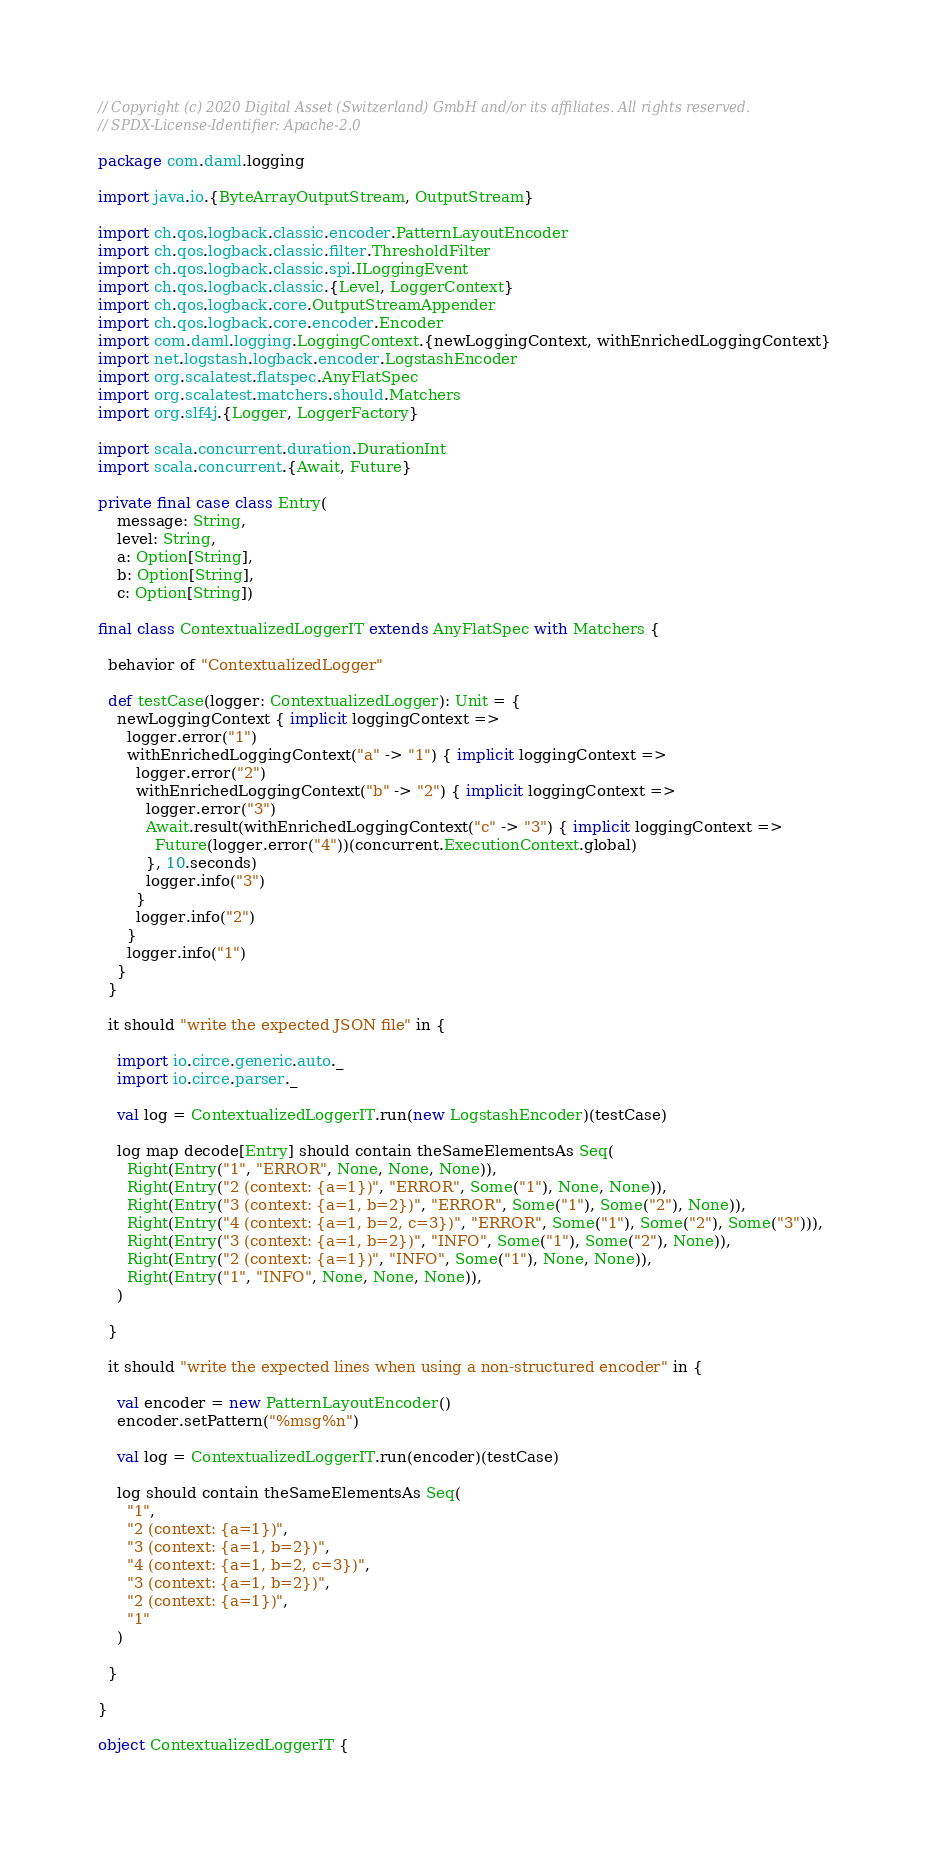<code> <loc_0><loc_0><loc_500><loc_500><_Scala_>// Copyright (c) 2020 Digital Asset (Switzerland) GmbH and/or its affiliates. All rights reserved.
// SPDX-License-Identifier: Apache-2.0

package com.daml.logging

import java.io.{ByteArrayOutputStream, OutputStream}

import ch.qos.logback.classic.encoder.PatternLayoutEncoder
import ch.qos.logback.classic.filter.ThresholdFilter
import ch.qos.logback.classic.spi.ILoggingEvent
import ch.qos.logback.classic.{Level, LoggerContext}
import ch.qos.logback.core.OutputStreamAppender
import ch.qos.logback.core.encoder.Encoder
import com.daml.logging.LoggingContext.{newLoggingContext, withEnrichedLoggingContext}
import net.logstash.logback.encoder.LogstashEncoder
import org.scalatest.flatspec.AnyFlatSpec
import org.scalatest.matchers.should.Matchers
import org.slf4j.{Logger, LoggerFactory}

import scala.concurrent.duration.DurationInt
import scala.concurrent.{Await, Future}

private final case class Entry(
    message: String,
    level: String,
    a: Option[String],
    b: Option[String],
    c: Option[String])

final class ContextualizedLoggerIT extends AnyFlatSpec with Matchers {

  behavior of "ContextualizedLogger"

  def testCase(logger: ContextualizedLogger): Unit = {
    newLoggingContext { implicit loggingContext =>
      logger.error("1")
      withEnrichedLoggingContext("a" -> "1") { implicit loggingContext =>
        logger.error("2")
        withEnrichedLoggingContext("b" -> "2") { implicit loggingContext =>
          logger.error("3")
          Await.result(withEnrichedLoggingContext("c" -> "3") { implicit loggingContext =>
            Future(logger.error("4"))(concurrent.ExecutionContext.global)
          }, 10.seconds)
          logger.info("3")
        }
        logger.info("2")
      }
      logger.info("1")
    }
  }

  it should "write the expected JSON file" in {

    import io.circe.generic.auto._
    import io.circe.parser._

    val log = ContextualizedLoggerIT.run(new LogstashEncoder)(testCase)

    log map decode[Entry] should contain theSameElementsAs Seq(
      Right(Entry("1", "ERROR", None, None, None)),
      Right(Entry("2 (context: {a=1})", "ERROR", Some("1"), None, None)),
      Right(Entry("3 (context: {a=1, b=2})", "ERROR", Some("1"), Some("2"), None)),
      Right(Entry("4 (context: {a=1, b=2, c=3})", "ERROR", Some("1"), Some("2"), Some("3"))),
      Right(Entry("3 (context: {a=1, b=2})", "INFO", Some("1"), Some("2"), None)),
      Right(Entry("2 (context: {a=1})", "INFO", Some("1"), None, None)),
      Right(Entry("1", "INFO", None, None, None)),
    )

  }

  it should "write the expected lines when using a non-structured encoder" in {

    val encoder = new PatternLayoutEncoder()
    encoder.setPattern("%msg%n")

    val log = ContextualizedLoggerIT.run(encoder)(testCase)

    log should contain theSameElementsAs Seq(
      "1",
      "2 (context: {a=1})",
      "3 (context: {a=1, b=2})",
      "4 (context: {a=1, b=2, c=3})",
      "3 (context: {a=1, b=2})",
      "2 (context: {a=1})",
      "1"
    )

  }

}

object ContextualizedLoggerIT {
</code> 